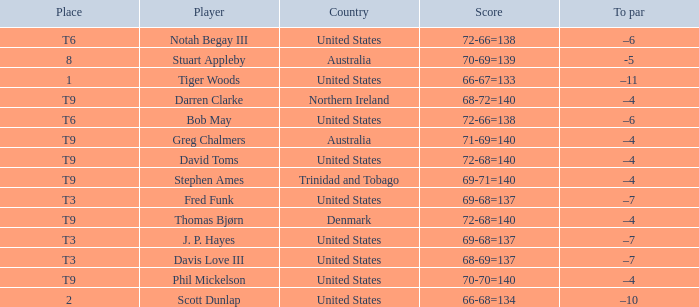What country is Darren Clarke from? Northern Ireland. 